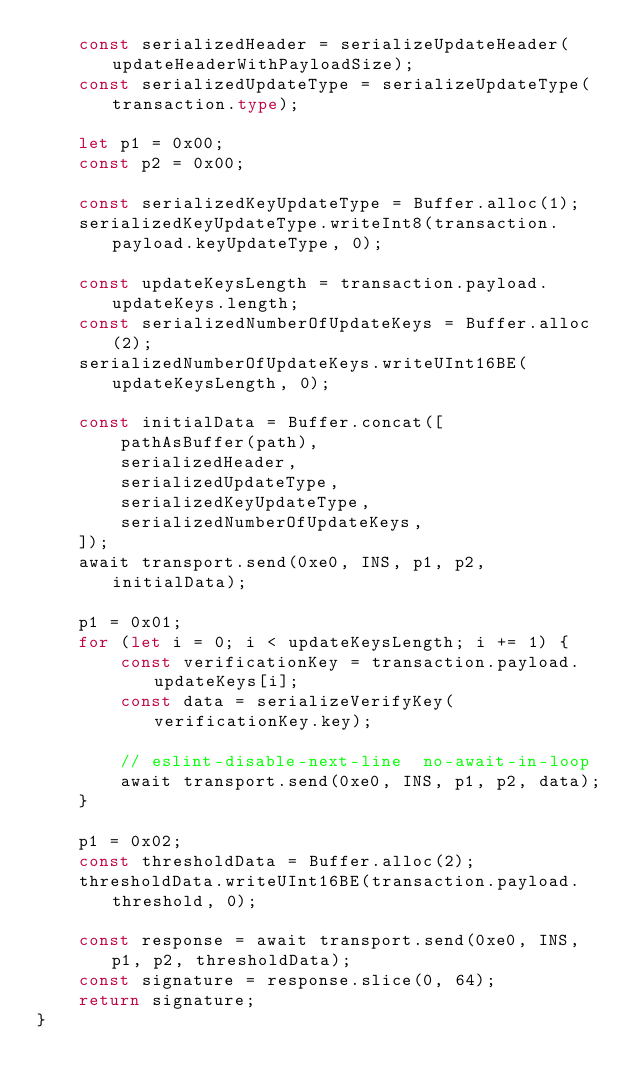Convert code to text. <code><loc_0><loc_0><loc_500><loc_500><_TypeScript_>    const serializedHeader = serializeUpdateHeader(updateHeaderWithPayloadSize);
    const serializedUpdateType = serializeUpdateType(transaction.type);

    let p1 = 0x00;
    const p2 = 0x00;

    const serializedKeyUpdateType = Buffer.alloc(1);
    serializedKeyUpdateType.writeInt8(transaction.payload.keyUpdateType, 0);

    const updateKeysLength = transaction.payload.updateKeys.length;
    const serializedNumberOfUpdateKeys = Buffer.alloc(2);
    serializedNumberOfUpdateKeys.writeUInt16BE(updateKeysLength, 0);

    const initialData = Buffer.concat([
        pathAsBuffer(path),
        serializedHeader,
        serializedUpdateType,
        serializedKeyUpdateType,
        serializedNumberOfUpdateKeys,
    ]);
    await transport.send(0xe0, INS, p1, p2, initialData);

    p1 = 0x01;
    for (let i = 0; i < updateKeysLength; i += 1) {
        const verificationKey = transaction.payload.updateKeys[i];
        const data = serializeVerifyKey(verificationKey.key);

        // eslint-disable-next-line  no-await-in-loop
        await transport.send(0xe0, INS, p1, p2, data);
    }

    p1 = 0x02;
    const thresholdData = Buffer.alloc(2);
    thresholdData.writeUInt16BE(transaction.payload.threshold, 0);

    const response = await transport.send(0xe0, INS, p1, p2, thresholdData);
    const signature = response.slice(0, 64);
    return signature;
}
</code> 